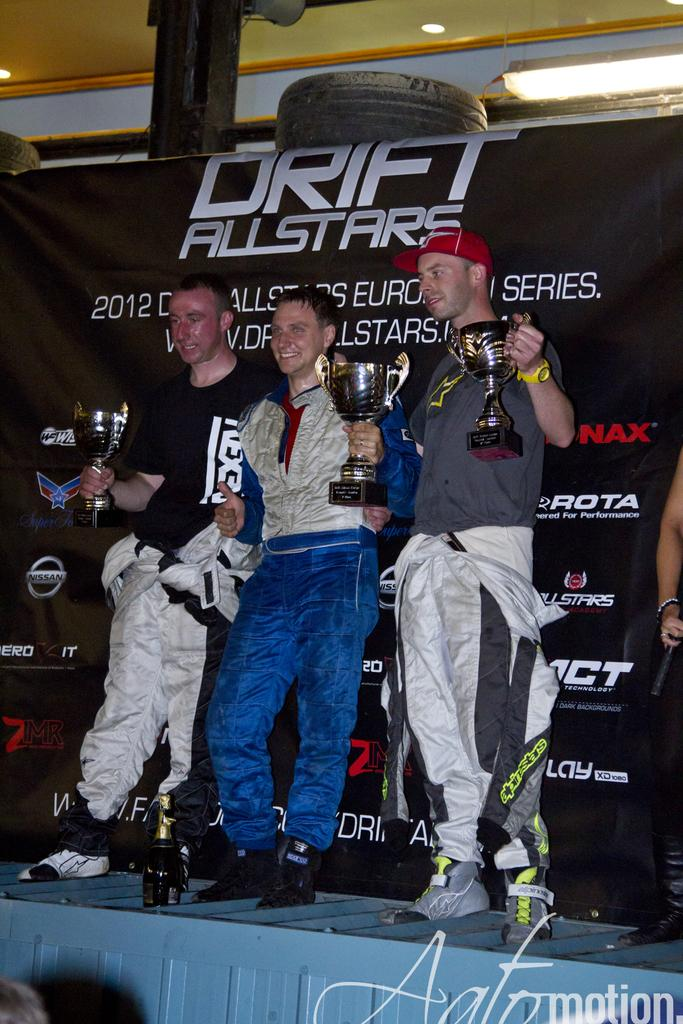<image>
Offer a succinct explanation of the picture presented. .m holding trophies beneath a sign that says Drift All Stars 